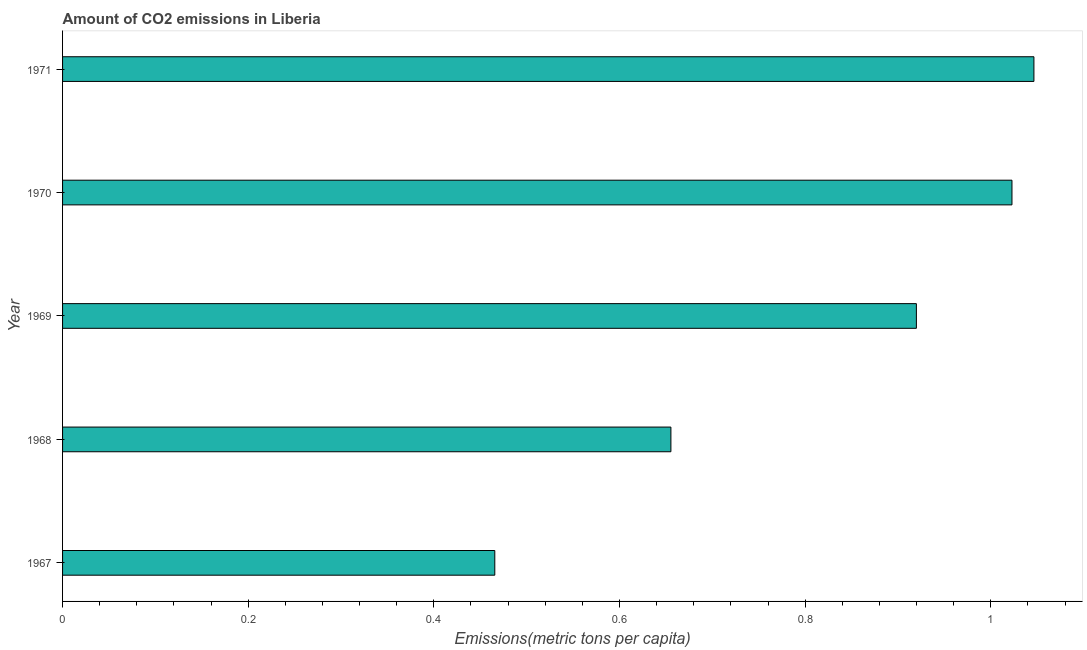Does the graph contain grids?
Your response must be concise. No. What is the title of the graph?
Give a very brief answer. Amount of CO2 emissions in Liberia. What is the label or title of the X-axis?
Provide a short and direct response. Emissions(metric tons per capita). What is the label or title of the Y-axis?
Your response must be concise. Year. What is the amount of co2 emissions in 1970?
Your answer should be very brief. 1.02. Across all years, what is the maximum amount of co2 emissions?
Provide a short and direct response. 1.05. Across all years, what is the minimum amount of co2 emissions?
Provide a succinct answer. 0.47. In which year was the amount of co2 emissions minimum?
Give a very brief answer. 1967. What is the sum of the amount of co2 emissions?
Make the answer very short. 4.11. What is the difference between the amount of co2 emissions in 1968 and 1971?
Give a very brief answer. -0.39. What is the average amount of co2 emissions per year?
Keep it short and to the point. 0.82. What is the median amount of co2 emissions?
Your answer should be compact. 0.92. Do a majority of the years between 1968 and 1970 (inclusive) have amount of co2 emissions greater than 1.04 metric tons per capita?
Your answer should be very brief. No. What is the ratio of the amount of co2 emissions in 1967 to that in 1970?
Provide a short and direct response. 0.46. Is the amount of co2 emissions in 1970 less than that in 1971?
Offer a terse response. Yes. What is the difference between the highest and the second highest amount of co2 emissions?
Make the answer very short. 0.02. What is the difference between the highest and the lowest amount of co2 emissions?
Provide a succinct answer. 0.58. In how many years, is the amount of co2 emissions greater than the average amount of co2 emissions taken over all years?
Give a very brief answer. 3. What is the difference between two consecutive major ticks on the X-axis?
Provide a short and direct response. 0.2. What is the Emissions(metric tons per capita) of 1967?
Your response must be concise. 0.47. What is the Emissions(metric tons per capita) in 1968?
Make the answer very short. 0.66. What is the Emissions(metric tons per capita) of 1969?
Provide a succinct answer. 0.92. What is the Emissions(metric tons per capita) in 1970?
Your answer should be compact. 1.02. What is the Emissions(metric tons per capita) of 1971?
Give a very brief answer. 1.05. What is the difference between the Emissions(metric tons per capita) in 1967 and 1968?
Ensure brevity in your answer.  -0.19. What is the difference between the Emissions(metric tons per capita) in 1967 and 1969?
Make the answer very short. -0.45. What is the difference between the Emissions(metric tons per capita) in 1967 and 1970?
Give a very brief answer. -0.56. What is the difference between the Emissions(metric tons per capita) in 1967 and 1971?
Your answer should be compact. -0.58. What is the difference between the Emissions(metric tons per capita) in 1968 and 1969?
Offer a terse response. -0.26. What is the difference between the Emissions(metric tons per capita) in 1968 and 1970?
Offer a very short reply. -0.37. What is the difference between the Emissions(metric tons per capita) in 1968 and 1971?
Provide a short and direct response. -0.39. What is the difference between the Emissions(metric tons per capita) in 1969 and 1970?
Provide a short and direct response. -0.1. What is the difference between the Emissions(metric tons per capita) in 1969 and 1971?
Offer a terse response. -0.13. What is the difference between the Emissions(metric tons per capita) in 1970 and 1971?
Ensure brevity in your answer.  -0.02. What is the ratio of the Emissions(metric tons per capita) in 1967 to that in 1968?
Offer a very short reply. 0.71. What is the ratio of the Emissions(metric tons per capita) in 1967 to that in 1969?
Your response must be concise. 0.51. What is the ratio of the Emissions(metric tons per capita) in 1967 to that in 1970?
Provide a short and direct response. 0.46. What is the ratio of the Emissions(metric tons per capita) in 1967 to that in 1971?
Offer a terse response. 0.45. What is the ratio of the Emissions(metric tons per capita) in 1968 to that in 1969?
Offer a very short reply. 0.71. What is the ratio of the Emissions(metric tons per capita) in 1968 to that in 1970?
Your answer should be compact. 0.64. What is the ratio of the Emissions(metric tons per capita) in 1968 to that in 1971?
Keep it short and to the point. 0.63. What is the ratio of the Emissions(metric tons per capita) in 1969 to that in 1970?
Offer a terse response. 0.9. What is the ratio of the Emissions(metric tons per capita) in 1969 to that in 1971?
Offer a very short reply. 0.88. What is the ratio of the Emissions(metric tons per capita) in 1970 to that in 1971?
Provide a succinct answer. 0.98. 